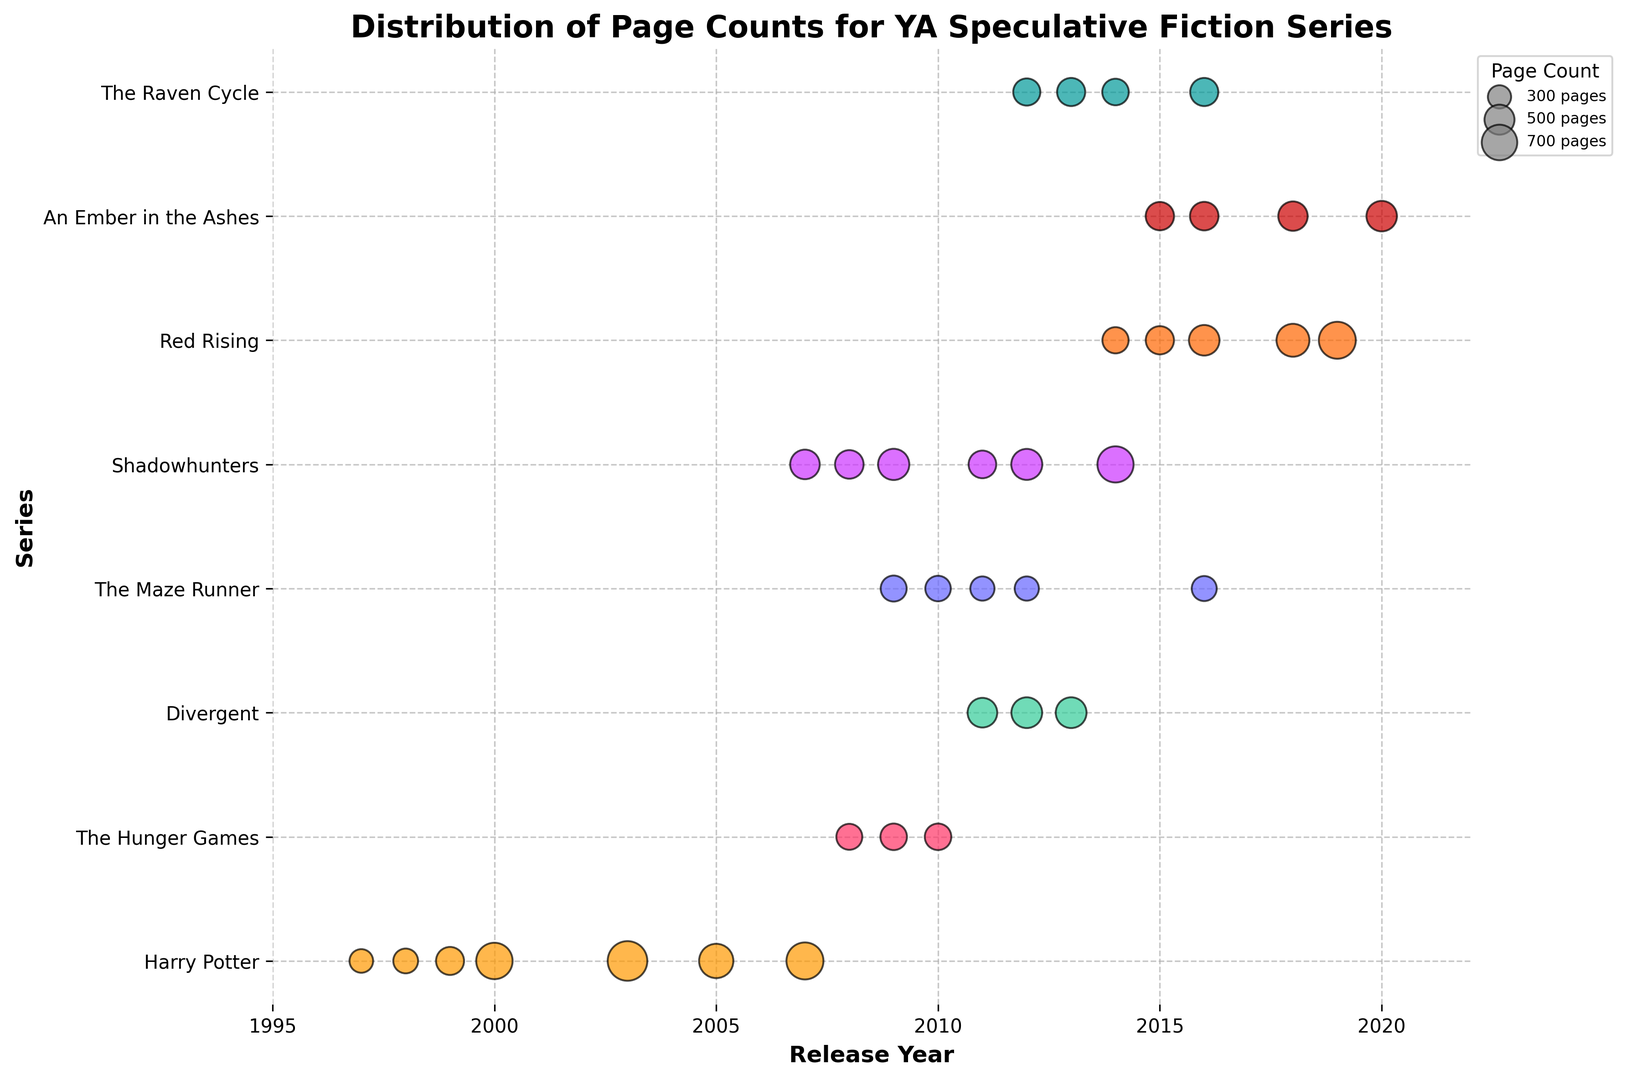What series has the book with the highest page count? The figure shows multiple series with varying page counts. The Harry Potter series has a book with the highest page count at 870 pages.
Answer: Harry Potter Which series appears most frequently on the plot? By counting the number of scatter points for each series, we can determine that "Shadowhunters" appears most frequently.
Answer: Shadowhunters Which year saw the release of the most books from any series? By counting the number of books released each year from the scatter points, the year 2011 saw the release of the most books.
Answer: 2011 What is the average page count of the "Red Rising" series over its release timeline? Adding the page counts of the "Red Rising" series (382, 442, 518, 601, 757) equals 2700. Dividing this sum by the number of books (5) gives an average of 540 pages.
Answer: 540 Which series has the smallest change in page count over its entire release? Observe the relative consistency in page sizes across series. "The Maze Runner" has the smallest change in page count (the range is from 325 to 375).
Answer: The Maze Runner How many books in the "Harry Potter" series have more than 500 pages? From the plot, the "Harry Potter" series shows three books with more than 500 pages (books 5 to 7).
Answer: 3 What is the difference in page count between the longest and shortest book in the "The Raven Cycle" series? The shortest book in the "The Raven Cycle" series is 391 pages, and the longest is 439 pages. The difference is 439 - 391 = 48 pages.
Answer: 48 Are there any series that had their longest book published in the same year as another series’ shortest book? By comparing years and page counts, there is no single year where one series has its longest book published in the same year as another series has its shortest book.
Answer: No Which series' books show the most gradual increase in page count over the years? By observing the trend lines of page count increase for all series, "Red Rising" shows the most gradual, consistent increase.
Answer: Red Rising 